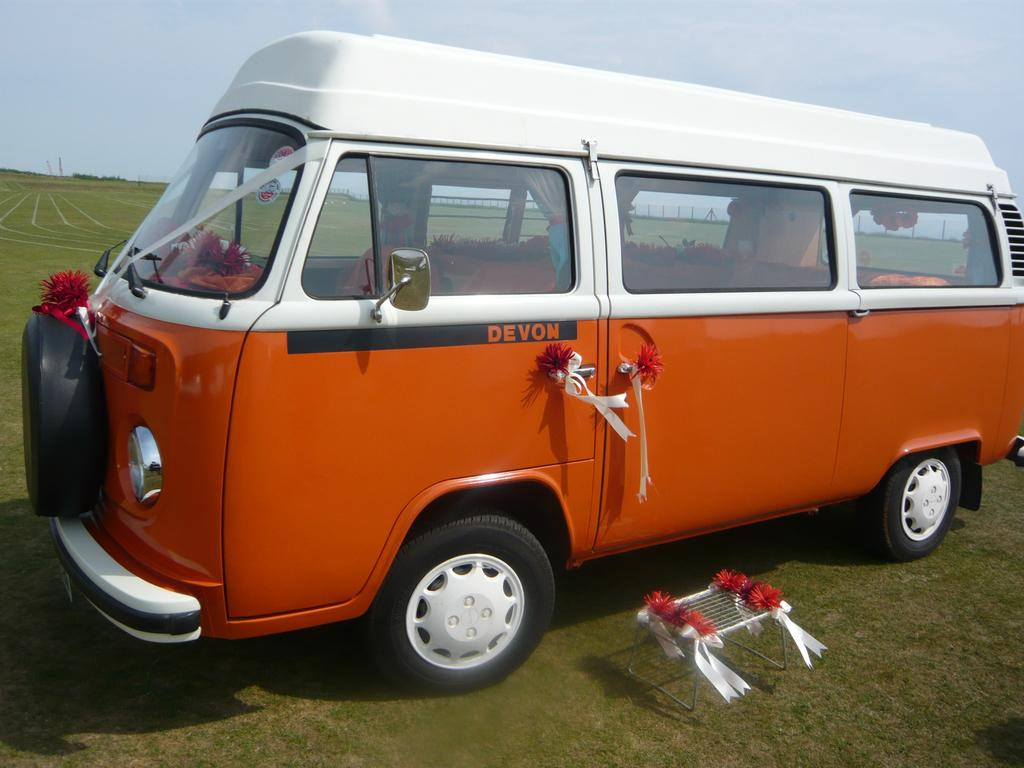<image>
Write a terse but informative summary of the picture. An orange VW van has the name DEVON written on the door 